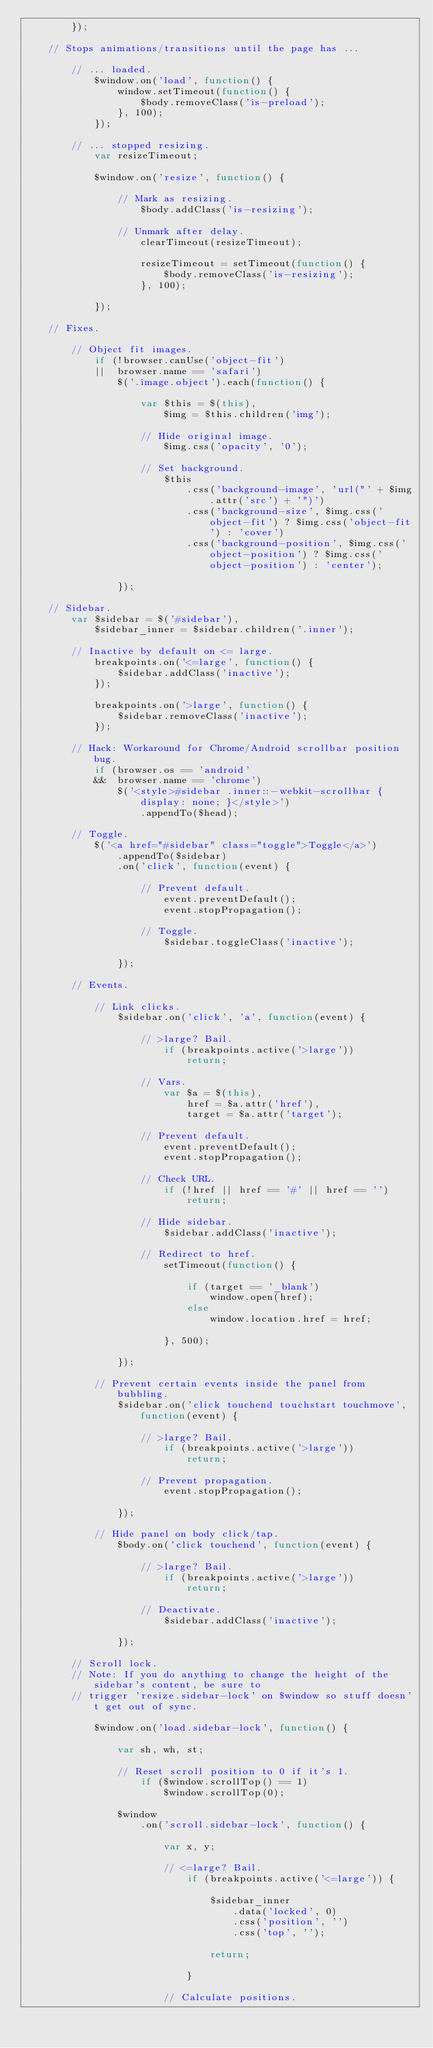Convert code to text. <code><loc_0><loc_0><loc_500><loc_500><_JavaScript_>		});

	// Stops animations/transitions until the page has ...

		// ... loaded.
			$window.on('load', function() {
				window.setTimeout(function() {
					$body.removeClass('is-preload');
				}, 100);
			});

		// ... stopped resizing.
			var resizeTimeout;

			$window.on('resize', function() {

				// Mark as resizing.
					$body.addClass('is-resizing');

				// Unmark after delay.
					clearTimeout(resizeTimeout);

					resizeTimeout = setTimeout(function() {
						$body.removeClass('is-resizing');
					}, 100);

			});

	// Fixes.

		// Object fit images.
			if (!browser.canUse('object-fit')
			||	browser.name == 'safari')
				$('.image.object').each(function() {

					var $this = $(this),
						$img = $this.children('img');

					// Hide original image.
						$img.css('opacity', '0');

					// Set background.
						$this
							.css('background-image', 'url("' + $img.attr('src') + '")')
							.css('background-size', $img.css('object-fit') ? $img.css('object-fit') : 'cover')
							.css('background-position', $img.css('object-position') ? $img.css('object-position') : 'center');

				});

	// Sidebar.
		var $sidebar = $('#sidebar'),
			$sidebar_inner = $sidebar.children('.inner');

		// Inactive by default on <= large.
			breakpoints.on('<=large', function() {
				$sidebar.addClass('inactive');
			});

			breakpoints.on('>large', function() {
				$sidebar.removeClass('inactive');
			});

		// Hack: Workaround for Chrome/Android scrollbar position bug.
			if (browser.os == 'android'
			&&	browser.name == 'chrome')
				$('<style>#sidebar .inner::-webkit-scrollbar { display: none; }</style>')
					.appendTo($head);

		// Toggle.
			$('<a href="#sidebar" class="toggle">Toggle</a>')
				.appendTo($sidebar)
				.on('click', function(event) {

					// Prevent default.
						event.preventDefault();
						event.stopPropagation();

					// Toggle.
						$sidebar.toggleClass('inactive');

				});

		// Events.

			// Link clicks.
				$sidebar.on('click', 'a', function(event) {

					// >large? Bail.
						if (breakpoints.active('>large'))
							return;

					// Vars.
						var $a = $(this),
							href = $a.attr('href'),
							target = $a.attr('target');

					// Prevent default.
						event.preventDefault();
						event.stopPropagation();

					// Check URL.
						if (!href || href == '#' || href == '')
							return;

					// Hide sidebar.
						$sidebar.addClass('inactive');

					// Redirect to href.
						setTimeout(function() {

							if (target == '_blank')
								window.open(href);
							else
								window.location.href = href;

						}, 500);

				});

			// Prevent certain events inside the panel from bubbling.
				$sidebar.on('click touchend touchstart touchmove', function(event) {

					// >large? Bail.
						if (breakpoints.active('>large'))
							return;

					// Prevent propagation.
						event.stopPropagation();

				});

			// Hide panel on body click/tap.
				$body.on('click touchend', function(event) {

					// >large? Bail.
						if (breakpoints.active('>large'))
							return;

					// Deactivate.
						$sidebar.addClass('inactive');

				});

		// Scroll lock.
		// Note: If you do anything to change the height of the sidebar's content, be sure to
		// trigger 'resize.sidebar-lock' on $window so stuff doesn't get out of sync.

			$window.on('load.sidebar-lock', function() {

				var sh, wh, st;

				// Reset scroll position to 0 if it's 1.
					if ($window.scrollTop() == 1)
						$window.scrollTop(0);

				$window
					.on('scroll.sidebar-lock', function() {

						var x, y;

						// <=large? Bail.
							if (breakpoints.active('<=large')) {

								$sidebar_inner
									.data('locked', 0)
									.css('position', '')
									.css('top', '');

								return;

							}

						// Calculate positions.</code> 